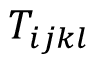<formula> <loc_0><loc_0><loc_500><loc_500>T _ { i j k l }</formula> 